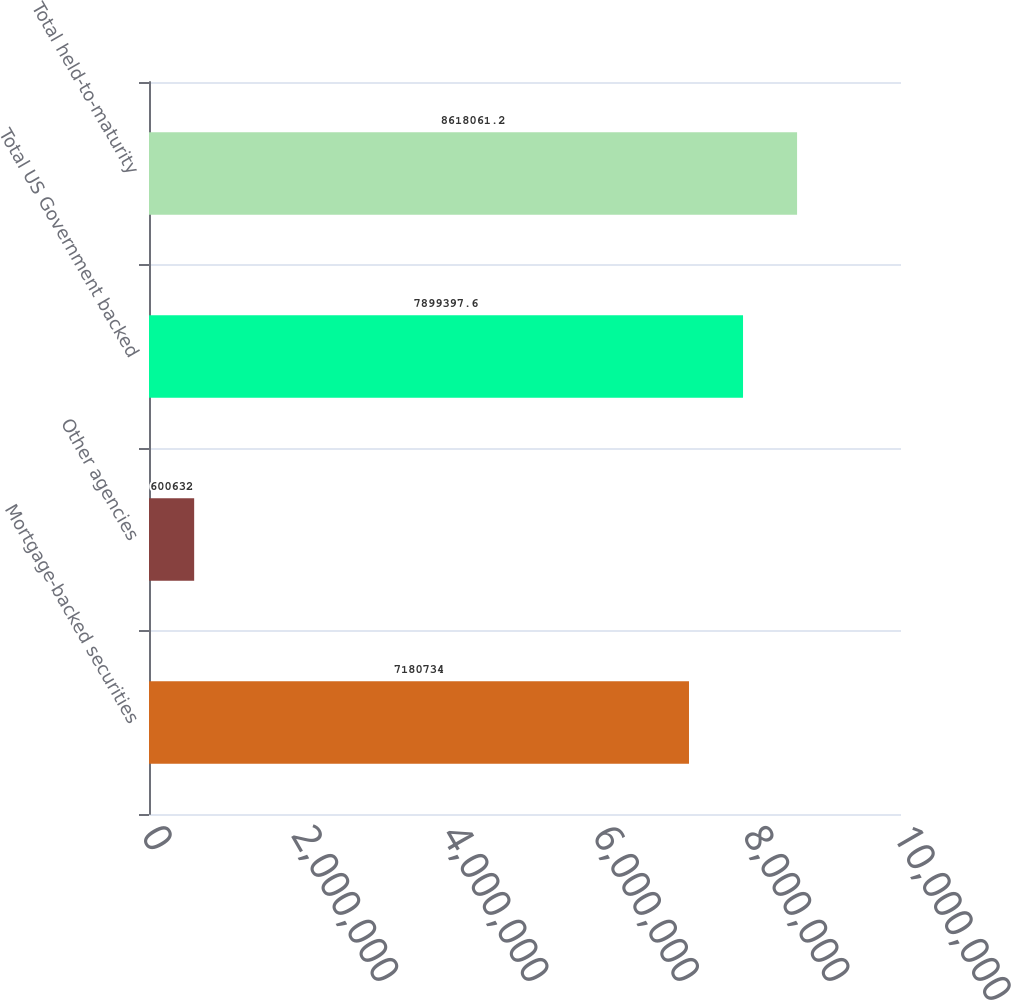Convert chart. <chart><loc_0><loc_0><loc_500><loc_500><bar_chart><fcel>Mortgage-backed securities<fcel>Other agencies<fcel>Total US Government backed<fcel>Total held-to-maturity<nl><fcel>7.18073e+06<fcel>600632<fcel>7.8994e+06<fcel>8.61806e+06<nl></chart> 